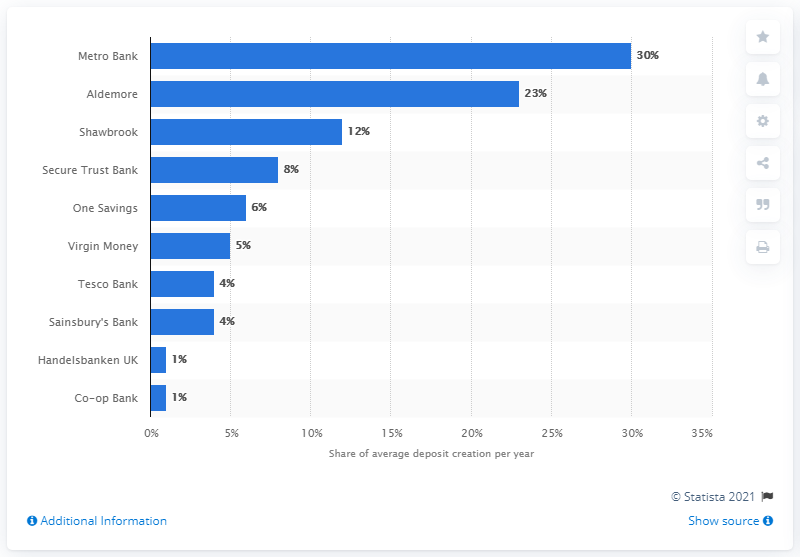Specify some key components in this picture. In 2014, Metro Bank made approximately 30% of their deposits. Metro Bank has consistently made an annual deposit creation of 30% since its establishment. 